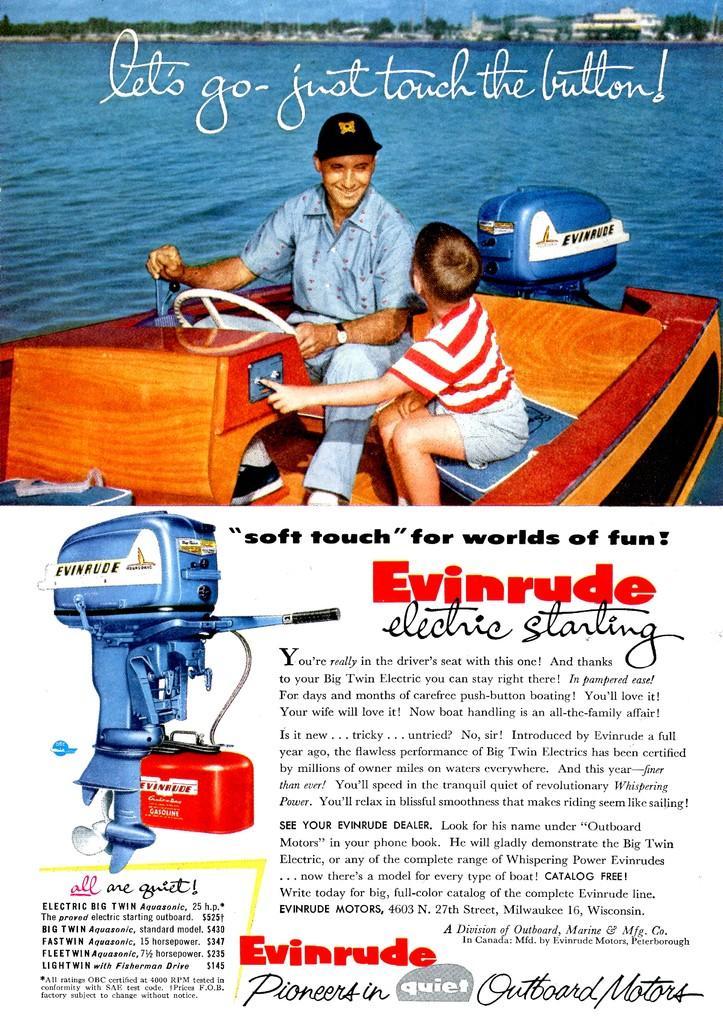Can you describe this image briefly? This is an advertisement. At the bottom of the image we can see the text and machine. At the top of the image we can see the sky, trees, buildings, water, poles and man, boy are sitting on a boat. 